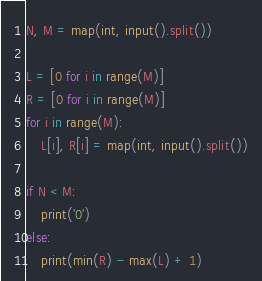Convert code to text. <code><loc_0><loc_0><loc_500><loc_500><_Python_>N, M = map(int, input().split())

L = [0 for i in range(M)]
R = [0 for i in range(M)]
for i in range(M):
    L[i], R[i] = map(int, input().split())

if N < M:
    print('0')
else:
    print(min(R) - max(L) + 1)</code> 